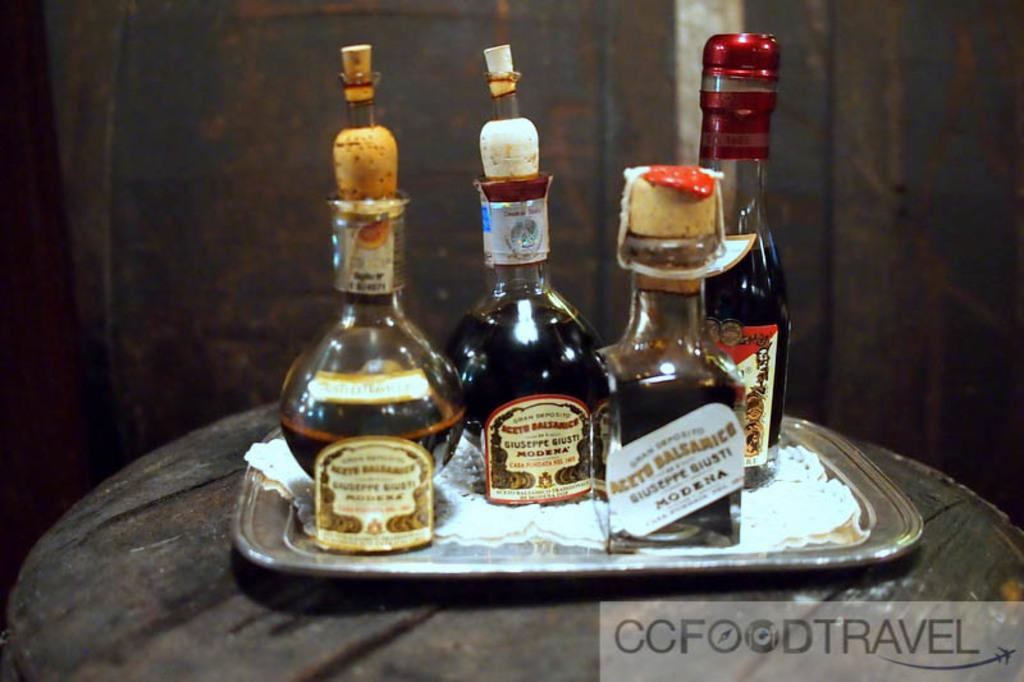<image>
Relay a brief, clear account of the picture shown. Bottles of Liquor on a tray from the label CC Food Travel. 